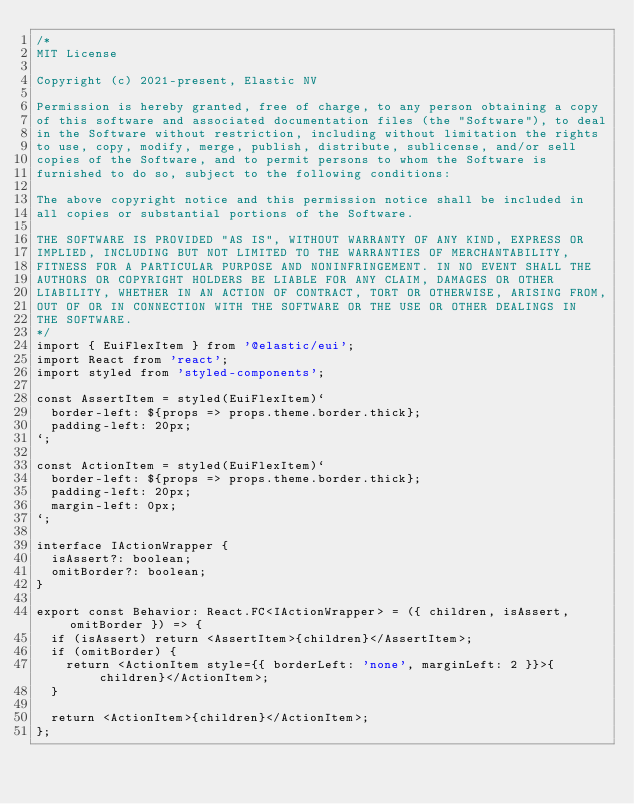<code> <loc_0><loc_0><loc_500><loc_500><_TypeScript_>/*
MIT License

Copyright (c) 2021-present, Elastic NV

Permission is hereby granted, free of charge, to any person obtaining a copy
of this software and associated documentation files (the "Software"), to deal
in the Software without restriction, including without limitation the rights
to use, copy, modify, merge, publish, distribute, sublicense, and/or sell
copies of the Software, and to permit persons to whom the Software is
furnished to do so, subject to the following conditions:

The above copyright notice and this permission notice shall be included in
all copies or substantial portions of the Software.

THE SOFTWARE IS PROVIDED "AS IS", WITHOUT WARRANTY OF ANY KIND, EXPRESS OR
IMPLIED, INCLUDING BUT NOT LIMITED TO THE WARRANTIES OF MERCHANTABILITY,
FITNESS FOR A PARTICULAR PURPOSE AND NONINFRINGEMENT. IN NO EVENT SHALL THE
AUTHORS OR COPYRIGHT HOLDERS BE LIABLE FOR ANY CLAIM, DAMAGES OR OTHER
LIABILITY, WHETHER IN AN ACTION OF CONTRACT, TORT OR OTHERWISE, ARISING FROM,
OUT OF OR IN CONNECTION WITH THE SOFTWARE OR THE USE OR OTHER DEALINGS IN
THE SOFTWARE.
*/
import { EuiFlexItem } from '@elastic/eui';
import React from 'react';
import styled from 'styled-components';

const AssertItem = styled(EuiFlexItem)`
  border-left: ${props => props.theme.border.thick};
  padding-left: 20px;
`;

const ActionItem = styled(EuiFlexItem)`
  border-left: ${props => props.theme.border.thick};
  padding-left: 20px;
  margin-left: 0px;
`;

interface IActionWrapper {
  isAssert?: boolean;
  omitBorder?: boolean;
}

export const Behavior: React.FC<IActionWrapper> = ({ children, isAssert, omitBorder }) => {
  if (isAssert) return <AssertItem>{children}</AssertItem>;
  if (omitBorder) {
    return <ActionItem style={{ borderLeft: 'none', marginLeft: 2 }}>{children}</ActionItem>;
  }

  return <ActionItem>{children}</ActionItem>;
};
</code> 